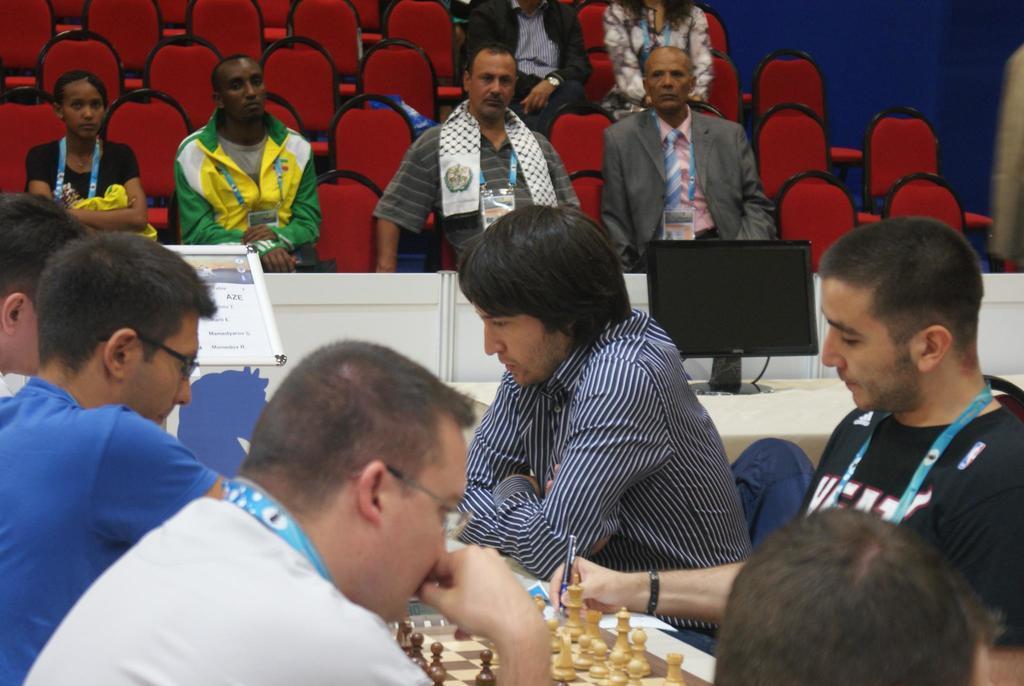Could you give a brief overview of what you see in this image? In this picture we can see few people, in front of them we can see a chess board with chess pieces and in the background we can see monitors on the desk and few people are sitting on chairs. 